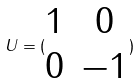<formula> <loc_0><loc_0><loc_500><loc_500>U = ( \begin{matrix} 1 & 0 \\ 0 & - 1 \end{matrix} )</formula> 